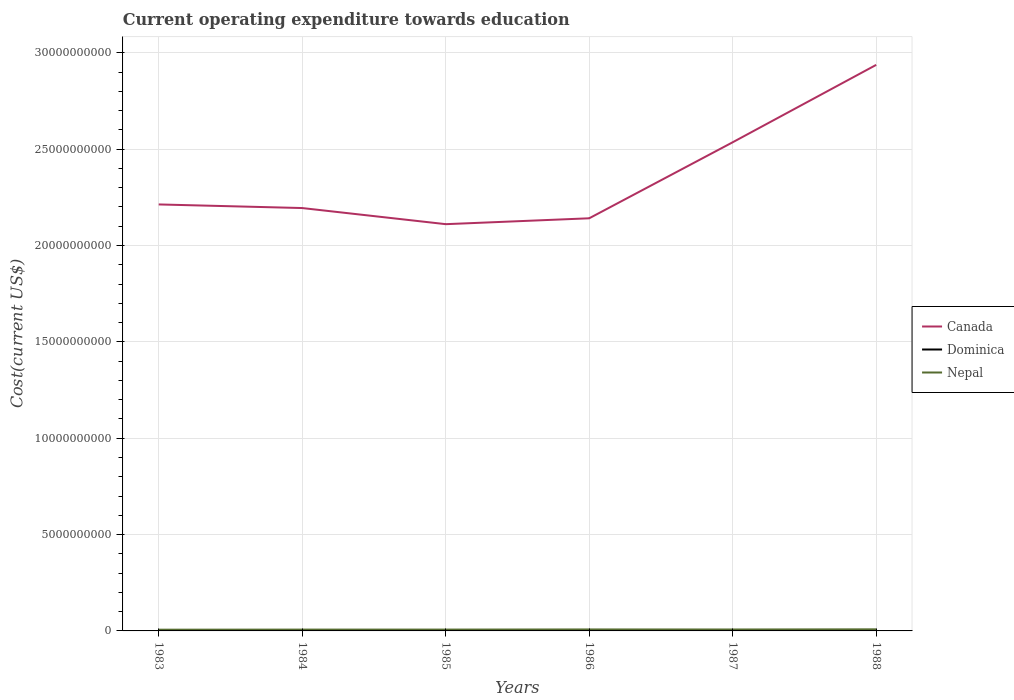Does the line corresponding to Dominica intersect with the line corresponding to Canada?
Keep it short and to the point. No. Is the number of lines equal to the number of legend labels?
Give a very brief answer. Yes. Across all years, what is the maximum expenditure towards education in Nepal?
Make the answer very short. 6.40e+07. In which year was the expenditure towards education in Nepal maximum?
Keep it short and to the point. 1983. What is the total expenditure towards education in Dominica in the graph?
Offer a very short reply. -1.57e+06. What is the difference between the highest and the second highest expenditure towards education in Nepal?
Your response must be concise. 1.85e+07. What is the difference between the highest and the lowest expenditure towards education in Dominica?
Your response must be concise. 3. Is the expenditure towards education in Canada strictly greater than the expenditure towards education in Nepal over the years?
Provide a succinct answer. No. How many lines are there?
Your answer should be compact. 3. How many years are there in the graph?
Keep it short and to the point. 6. Where does the legend appear in the graph?
Your response must be concise. Center right. What is the title of the graph?
Your answer should be very brief. Current operating expenditure towards education. What is the label or title of the Y-axis?
Offer a very short reply. Cost(current US$). What is the Cost(current US$) of Canada in 1983?
Your answer should be very brief. 2.21e+1. What is the Cost(current US$) of Dominica in 1983?
Provide a succinct answer. 4.29e+06. What is the Cost(current US$) of Nepal in 1983?
Your response must be concise. 6.40e+07. What is the Cost(current US$) in Canada in 1984?
Provide a succinct answer. 2.19e+1. What is the Cost(current US$) in Dominica in 1984?
Ensure brevity in your answer.  4.75e+06. What is the Cost(current US$) of Nepal in 1984?
Provide a short and direct response. 6.91e+07. What is the Cost(current US$) in Canada in 1985?
Keep it short and to the point. 2.11e+1. What is the Cost(current US$) in Dominica in 1985?
Your answer should be very brief. 5.04e+06. What is the Cost(current US$) in Nepal in 1985?
Your response must be concise. 6.99e+07. What is the Cost(current US$) in Canada in 1986?
Provide a succinct answer. 2.14e+1. What is the Cost(current US$) in Dominica in 1986?
Provide a short and direct response. 5.92e+06. What is the Cost(current US$) in Nepal in 1986?
Offer a very short reply. 7.70e+07. What is the Cost(current US$) of Canada in 1987?
Ensure brevity in your answer.  2.54e+1. What is the Cost(current US$) of Dominica in 1987?
Make the answer very short. 6.32e+06. What is the Cost(current US$) in Nepal in 1987?
Your response must be concise. 7.49e+07. What is the Cost(current US$) in Canada in 1988?
Your answer should be compact. 2.94e+1. What is the Cost(current US$) in Dominica in 1988?
Offer a very short reply. 6.42e+06. What is the Cost(current US$) in Nepal in 1988?
Your response must be concise. 8.24e+07. Across all years, what is the maximum Cost(current US$) of Canada?
Ensure brevity in your answer.  2.94e+1. Across all years, what is the maximum Cost(current US$) in Dominica?
Your response must be concise. 6.42e+06. Across all years, what is the maximum Cost(current US$) in Nepal?
Ensure brevity in your answer.  8.24e+07. Across all years, what is the minimum Cost(current US$) in Canada?
Ensure brevity in your answer.  2.11e+1. Across all years, what is the minimum Cost(current US$) of Dominica?
Your answer should be very brief. 4.29e+06. Across all years, what is the minimum Cost(current US$) of Nepal?
Provide a succinct answer. 6.40e+07. What is the total Cost(current US$) of Canada in the graph?
Ensure brevity in your answer.  1.41e+11. What is the total Cost(current US$) of Dominica in the graph?
Offer a very short reply. 3.27e+07. What is the total Cost(current US$) in Nepal in the graph?
Your answer should be very brief. 4.37e+08. What is the difference between the Cost(current US$) in Canada in 1983 and that in 1984?
Provide a succinct answer. 1.88e+08. What is the difference between the Cost(current US$) of Dominica in 1983 and that in 1984?
Offer a terse response. -4.55e+05. What is the difference between the Cost(current US$) of Nepal in 1983 and that in 1984?
Your response must be concise. -5.08e+06. What is the difference between the Cost(current US$) of Canada in 1983 and that in 1985?
Ensure brevity in your answer.  1.02e+09. What is the difference between the Cost(current US$) of Dominica in 1983 and that in 1985?
Offer a terse response. -7.48e+05. What is the difference between the Cost(current US$) in Nepal in 1983 and that in 1985?
Make the answer very short. -5.90e+06. What is the difference between the Cost(current US$) of Canada in 1983 and that in 1986?
Your response must be concise. 7.19e+08. What is the difference between the Cost(current US$) in Dominica in 1983 and that in 1986?
Keep it short and to the point. -1.62e+06. What is the difference between the Cost(current US$) of Nepal in 1983 and that in 1986?
Your answer should be very brief. -1.30e+07. What is the difference between the Cost(current US$) in Canada in 1983 and that in 1987?
Your response must be concise. -3.23e+09. What is the difference between the Cost(current US$) of Dominica in 1983 and that in 1987?
Your answer should be very brief. -2.03e+06. What is the difference between the Cost(current US$) in Nepal in 1983 and that in 1987?
Your answer should be very brief. -1.09e+07. What is the difference between the Cost(current US$) of Canada in 1983 and that in 1988?
Provide a short and direct response. -7.24e+09. What is the difference between the Cost(current US$) of Dominica in 1983 and that in 1988?
Offer a very short reply. -2.12e+06. What is the difference between the Cost(current US$) in Nepal in 1983 and that in 1988?
Provide a short and direct response. -1.85e+07. What is the difference between the Cost(current US$) in Canada in 1984 and that in 1985?
Provide a short and direct response. 8.36e+08. What is the difference between the Cost(current US$) of Dominica in 1984 and that in 1985?
Provide a short and direct response. -2.94e+05. What is the difference between the Cost(current US$) in Nepal in 1984 and that in 1985?
Keep it short and to the point. -8.18e+05. What is the difference between the Cost(current US$) of Canada in 1984 and that in 1986?
Offer a very short reply. 5.31e+08. What is the difference between the Cost(current US$) in Dominica in 1984 and that in 1986?
Provide a short and direct response. -1.17e+06. What is the difference between the Cost(current US$) in Nepal in 1984 and that in 1986?
Make the answer very short. -7.92e+06. What is the difference between the Cost(current US$) in Canada in 1984 and that in 1987?
Give a very brief answer. -3.41e+09. What is the difference between the Cost(current US$) in Dominica in 1984 and that in 1987?
Your response must be concise. -1.57e+06. What is the difference between the Cost(current US$) in Nepal in 1984 and that in 1987?
Make the answer very short. -5.84e+06. What is the difference between the Cost(current US$) of Canada in 1984 and that in 1988?
Give a very brief answer. -7.43e+09. What is the difference between the Cost(current US$) in Dominica in 1984 and that in 1988?
Offer a terse response. -1.67e+06. What is the difference between the Cost(current US$) in Nepal in 1984 and that in 1988?
Give a very brief answer. -1.34e+07. What is the difference between the Cost(current US$) in Canada in 1985 and that in 1986?
Provide a succinct answer. -3.05e+08. What is the difference between the Cost(current US$) of Dominica in 1985 and that in 1986?
Provide a short and direct response. -8.74e+05. What is the difference between the Cost(current US$) in Nepal in 1985 and that in 1986?
Give a very brief answer. -7.10e+06. What is the difference between the Cost(current US$) of Canada in 1985 and that in 1987?
Offer a terse response. -4.25e+09. What is the difference between the Cost(current US$) of Dominica in 1985 and that in 1987?
Provide a short and direct response. -1.28e+06. What is the difference between the Cost(current US$) of Nepal in 1985 and that in 1987?
Offer a very short reply. -5.02e+06. What is the difference between the Cost(current US$) of Canada in 1985 and that in 1988?
Provide a succinct answer. -8.27e+09. What is the difference between the Cost(current US$) in Dominica in 1985 and that in 1988?
Your answer should be very brief. -1.37e+06. What is the difference between the Cost(current US$) in Nepal in 1985 and that in 1988?
Give a very brief answer. -1.26e+07. What is the difference between the Cost(current US$) in Canada in 1986 and that in 1987?
Your answer should be very brief. -3.94e+09. What is the difference between the Cost(current US$) in Dominica in 1986 and that in 1987?
Provide a short and direct response. -4.04e+05. What is the difference between the Cost(current US$) in Nepal in 1986 and that in 1987?
Provide a succinct answer. 2.08e+06. What is the difference between the Cost(current US$) of Canada in 1986 and that in 1988?
Your answer should be compact. -7.96e+09. What is the difference between the Cost(current US$) of Dominica in 1986 and that in 1988?
Ensure brevity in your answer.  -4.98e+05. What is the difference between the Cost(current US$) of Nepal in 1986 and that in 1988?
Provide a succinct answer. -5.48e+06. What is the difference between the Cost(current US$) of Canada in 1987 and that in 1988?
Provide a succinct answer. -4.02e+09. What is the difference between the Cost(current US$) of Dominica in 1987 and that in 1988?
Provide a short and direct response. -9.50e+04. What is the difference between the Cost(current US$) of Nepal in 1987 and that in 1988?
Provide a succinct answer. -7.56e+06. What is the difference between the Cost(current US$) in Canada in 1983 and the Cost(current US$) in Dominica in 1984?
Ensure brevity in your answer.  2.21e+1. What is the difference between the Cost(current US$) in Canada in 1983 and the Cost(current US$) in Nepal in 1984?
Give a very brief answer. 2.21e+1. What is the difference between the Cost(current US$) in Dominica in 1983 and the Cost(current US$) in Nepal in 1984?
Your answer should be compact. -6.48e+07. What is the difference between the Cost(current US$) in Canada in 1983 and the Cost(current US$) in Dominica in 1985?
Keep it short and to the point. 2.21e+1. What is the difference between the Cost(current US$) in Canada in 1983 and the Cost(current US$) in Nepal in 1985?
Give a very brief answer. 2.21e+1. What is the difference between the Cost(current US$) of Dominica in 1983 and the Cost(current US$) of Nepal in 1985?
Give a very brief answer. -6.56e+07. What is the difference between the Cost(current US$) in Canada in 1983 and the Cost(current US$) in Dominica in 1986?
Give a very brief answer. 2.21e+1. What is the difference between the Cost(current US$) of Canada in 1983 and the Cost(current US$) of Nepal in 1986?
Provide a short and direct response. 2.21e+1. What is the difference between the Cost(current US$) of Dominica in 1983 and the Cost(current US$) of Nepal in 1986?
Your answer should be compact. -7.27e+07. What is the difference between the Cost(current US$) in Canada in 1983 and the Cost(current US$) in Dominica in 1987?
Make the answer very short. 2.21e+1. What is the difference between the Cost(current US$) of Canada in 1983 and the Cost(current US$) of Nepal in 1987?
Your answer should be compact. 2.21e+1. What is the difference between the Cost(current US$) in Dominica in 1983 and the Cost(current US$) in Nepal in 1987?
Give a very brief answer. -7.06e+07. What is the difference between the Cost(current US$) in Canada in 1983 and the Cost(current US$) in Dominica in 1988?
Your answer should be very brief. 2.21e+1. What is the difference between the Cost(current US$) in Canada in 1983 and the Cost(current US$) in Nepal in 1988?
Give a very brief answer. 2.20e+1. What is the difference between the Cost(current US$) of Dominica in 1983 and the Cost(current US$) of Nepal in 1988?
Give a very brief answer. -7.82e+07. What is the difference between the Cost(current US$) in Canada in 1984 and the Cost(current US$) in Dominica in 1985?
Give a very brief answer. 2.19e+1. What is the difference between the Cost(current US$) in Canada in 1984 and the Cost(current US$) in Nepal in 1985?
Your response must be concise. 2.19e+1. What is the difference between the Cost(current US$) in Dominica in 1984 and the Cost(current US$) in Nepal in 1985?
Ensure brevity in your answer.  -6.51e+07. What is the difference between the Cost(current US$) in Canada in 1984 and the Cost(current US$) in Dominica in 1986?
Keep it short and to the point. 2.19e+1. What is the difference between the Cost(current US$) in Canada in 1984 and the Cost(current US$) in Nepal in 1986?
Your answer should be compact. 2.19e+1. What is the difference between the Cost(current US$) of Dominica in 1984 and the Cost(current US$) of Nepal in 1986?
Provide a succinct answer. -7.22e+07. What is the difference between the Cost(current US$) of Canada in 1984 and the Cost(current US$) of Dominica in 1987?
Provide a short and direct response. 2.19e+1. What is the difference between the Cost(current US$) of Canada in 1984 and the Cost(current US$) of Nepal in 1987?
Provide a short and direct response. 2.19e+1. What is the difference between the Cost(current US$) of Dominica in 1984 and the Cost(current US$) of Nepal in 1987?
Your answer should be compact. -7.01e+07. What is the difference between the Cost(current US$) in Canada in 1984 and the Cost(current US$) in Dominica in 1988?
Make the answer very short. 2.19e+1. What is the difference between the Cost(current US$) in Canada in 1984 and the Cost(current US$) in Nepal in 1988?
Provide a succinct answer. 2.19e+1. What is the difference between the Cost(current US$) of Dominica in 1984 and the Cost(current US$) of Nepal in 1988?
Give a very brief answer. -7.77e+07. What is the difference between the Cost(current US$) in Canada in 1985 and the Cost(current US$) in Dominica in 1986?
Give a very brief answer. 2.11e+1. What is the difference between the Cost(current US$) of Canada in 1985 and the Cost(current US$) of Nepal in 1986?
Give a very brief answer. 2.10e+1. What is the difference between the Cost(current US$) of Dominica in 1985 and the Cost(current US$) of Nepal in 1986?
Ensure brevity in your answer.  -7.19e+07. What is the difference between the Cost(current US$) in Canada in 1985 and the Cost(current US$) in Dominica in 1987?
Your answer should be very brief. 2.11e+1. What is the difference between the Cost(current US$) in Canada in 1985 and the Cost(current US$) in Nepal in 1987?
Offer a terse response. 2.10e+1. What is the difference between the Cost(current US$) in Dominica in 1985 and the Cost(current US$) in Nepal in 1987?
Ensure brevity in your answer.  -6.99e+07. What is the difference between the Cost(current US$) of Canada in 1985 and the Cost(current US$) of Dominica in 1988?
Ensure brevity in your answer.  2.11e+1. What is the difference between the Cost(current US$) in Canada in 1985 and the Cost(current US$) in Nepal in 1988?
Keep it short and to the point. 2.10e+1. What is the difference between the Cost(current US$) in Dominica in 1985 and the Cost(current US$) in Nepal in 1988?
Ensure brevity in your answer.  -7.74e+07. What is the difference between the Cost(current US$) in Canada in 1986 and the Cost(current US$) in Dominica in 1987?
Ensure brevity in your answer.  2.14e+1. What is the difference between the Cost(current US$) of Canada in 1986 and the Cost(current US$) of Nepal in 1987?
Provide a short and direct response. 2.13e+1. What is the difference between the Cost(current US$) in Dominica in 1986 and the Cost(current US$) in Nepal in 1987?
Your answer should be very brief. -6.90e+07. What is the difference between the Cost(current US$) of Canada in 1986 and the Cost(current US$) of Dominica in 1988?
Keep it short and to the point. 2.14e+1. What is the difference between the Cost(current US$) in Canada in 1986 and the Cost(current US$) in Nepal in 1988?
Your answer should be very brief. 2.13e+1. What is the difference between the Cost(current US$) in Dominica in 1986 and the Cost(current US$) in Nepal in 1988?
Offer a terse response. -7.65e+07. What is the difference between the Cost(current US$) in Canada in 1987 and the Cost(current US$) in Dominica in 1988?
Give a very brief answer. 2.53e+1. What is the difference between the Cost(current US$) in Canada in 1987 and the Cost(current US$) in Nepal in 1988?
Your response must be concise. 2.53e+1. What is the difference between the Cost(current US$) in Dominica in 1987 and the Cost(current US$) in Nepal in 1988?
Your answer should be very brief. -7.61e+07. What is the average Cost(current US$) of Canada per year?
Offer a very short reply. 2.36e+1. What is the average Cost(current US$) in Dominica per year?
Keep it short and to the point. 5.46e+06. What is the average Cost(current US$) of Nepal per year?
Provide a short and direct response. 7.29e+07. In the year 1983, what is the difference between the Cost(current US$) of Canada and Cost(current US$) of Dominica?
Offer a very short reply. 2.21e+1. In the year 1983, what is the difference between the Cost(current US$) of Canada and Cost(current US$) of Nepal?
Provide a succinct answer. 2.21e+1. In the year 1983, what is the difference between the Cost(current US$) of Dominica and Cost(current US$) of Nepal?
Your answer should be very brief. -5.97e+07. In the year 1984, what is the difference between the Cost(current US$) of Canada and Cost(current US$) of Dominica?
Keep it short and to the point. 2.19e+1. In the year 1984, what is the difference between the Cost(current US$) in Canada and Cost(current US$) in Nepal?
Your answer should be compact. 2.19e+1. In the year 1984, what is the difference between the Cost(current US$) in Dominica and Cost(current US$) in Nepal?
Your response must be concise. -6.43e+07. In the year 1985, what is the difference between the Cost(current US$) in Canada and Cost(current US$) in Dominica?
Your answer should be compact. 2.11e+1. In the year 1985, what is the difference between the Cost(current US$) in Canada and Cost(current US$) in Nepal?
Your answer should be compact. 2.10e+1. In the year 1985, what is the difference between the Cost(current US$) in Dominica and Cost(current US$) in Nepal?
Ensure brevity in your answer.  -6.48e+07. In the year 1986, what is the difference between the Cost(current US$) in Canada and Cost(current US$) in Dominica?
Give a very brief answer. 2.14e+1. In the year 1986, what is the difference between the Cost(current US$) in Canada and Cost(current US$) in Nepal?
Your answer should be compact. 2.13e+1. In the year 1986, what is the difference between the Cost(current US$) of Dominica and Cost(current US$) of Nepal?
Offer a terse response. -7.11e+07. In the year 1987, what is the difference between the Cost(current US$) in Canada and Cost(current US$) in Dominica?
Give a very brief answer. 2.53e+1. In the year 1987, what is the difference between the Cost(current US$) in Canada and Cost(current US$) in Nepal?
Your answer should be compact. 2.53e+1. In the year 1987, what is the difference between the Cost(current US$) of Dominica and Cost(current US$) of Nepal?
Provide a short and direct response. -6.86e+07. In the year 1988, what is the difference between the Cost(current US$) of Canada and Cost(current US$) of Dominica?
Provide a short and direct response. 2.94e+1. In the year 1988, what is the difference between the Cost(current US$) of Canada and Cost(current US$) of Nepal?
Make the answer very short. 2.93e+1. In the year 1988, what is the difference between the Cost(current US$) of Dominica and Cost(current US$) of Nepal?
Offer a terse response. -7.60e+07. What is the ratio of the Cost(current US$) in Canada in 1983 to that in 1984?
Provide a short and direct response. 1.01. What is the ratio of the Cost(current US$) of Dominica in 1983 to that in 1984?
Provide a short and direct response. 0.9. What is the ratio of the Cost(current US$) in Nepal in 1983 to that in 1984?
Ensure brevity in your answer.  0.93. What is the ratio of the Cost(current US$) in Canada in 1983 to that in 1985?
Offer a terse response. 1.05. What is the ratio of the Cost(current US$) in Dominica in 1983 to that in 1985?
Provide a succinct answer. 0.85. What is the ratio of the Cost(current US$) in Nepal in 1983 to that in 1985?
Offer a very short reply. 0.92. What is the ratio of the Cost(current US$) of Canada in 1983 to that in 1986?
Make the answer very short. 1.03. What is the ratio of the Cost(current US$) of Dominica in 1983 to that in 1986?
Your answer should be very brief. 0.73. What is the ratio of the Cost(current US$) in Nepal in 1983 to that in 1986?
Ensure brevity in your answer.  0.83. What is the ratio of the Cost(current US$) of Canada in 1983 to that in 1987?
Give a very brief answer. 0.87. What is the ratio of the Cost(current US$) of Dominica in 1983 to that in 1987?
Your answer should be compact. 0.68. What is the ratio of the Cost(current US$) in Nepal in 1983 to that in 1987?
Ensure brevity in your answer.  0.85. What is the ratio of the Cost(current US$) of Canada in 1983 to that in 1988?
Ensure brevity in your answer.  0.75. What is the ratio of the Cost(current US$) of Dominica in 1983 to that in 1988?
Offer a terse response. 0.67. What is the ratio of the Cost(current US$) of Nepal in 1983 to that in 1988?
Ensure brevity in your answer.  0.78. What is the ratio of the Cost(current US$) of Canada in 1984 to that in 1985?
Your answer should be compact. 1.04. What is the ratio of the Cost(current US$) in Dominica in 1984 to that in 1985?
Ensure brevity in your answer.  0.94. What is the ratio of the Cost(current US$) in Nepal in 1984 to that in 1985?
Keep it short and to the point. 0.99. What is the ratio of the Cost(current US$) in Canada in 1984 to that in 1986?
Your answer should be compact. 1.02. What is the ratio of the Cost(current US$) of Dominica in 1984 to that in 1986?
Keep it short and to the point. 0.8. What is the ratio of the Cost(current US$) of Nepal in 1984 to that in 1986?
Offer a very short reply. 0.9. What is the ratio of the Cost(current US$) in Canada in 1984 to that in 1987?
Your answer should be compact. 0.87. What is the ratio of the Cost(current US$) in Dominica in 1984 to that in 1987?
Keep it short and to the point. 0.75. What is the ratio of the Cost(current US$) of Nepal in 1984 to that in 1987?
Provide a succinct answer. 0.92. What is the ratio of the Cost(current US$) in Canada in 1984 to that in 1988?
Make the answer very short. 0.75. What is the ratio of the Cost(current US$) of Dominica in 1984 to that in 1988?
Provide a short and direct response. 0.74. What is the ratio of the Cost(current US$) of Nepal in 1984 to that in 1988?
Ensure brevity in your answer.  0.84. What is the ratio of the Cost(current US$) of Canada in 1985 to that in 1986?
Provide a succinct answer. 0.99. What is the ratio of the Cost(current US$) in Dominica in 1985 to that in 1986?
Your answer should be very brief. 0.85. What is the ratio of the Cost(current US$) in Nepal in 1985 to that in 1986?
Make the answer very short. 0.91. What is the ratio of the Cost(current US$) of Canada in 1985 to that in 1987?
Make the answer very short. 0.83. What is the ratio of the Cost(current US$) in Dominica in 1985 to that in 1987?
Make the answer very short. 0.8. What is the ratio of the Cost(current US$) in Nepal in 1985 to that in 1987?
Offer a very short reply. 0.93. What is the ratio of the Cost(current US$) in Canada in 1985 to that in 1988?
Keep it short and to the point. 0.72. What is the ratio of the Cost(current US$) of Dominica in 1985 to that in 1988?
Make the answer very short. 0.79. What is the ratio of the Cost(current US$) in Nepal in 1985 to that in 1988?
Your answer should be compact. 0.85. What is the ratio of the Cost(current US$) in Canada in 1986 to that in 1987?
Provide a short and direct response. 0.84. What is the ratio of the Cost(current US$) of Dominica in 1986 to that in 1987?
Offer a terse response. 0.94. What is the ratio of the Cost(current US$) in Nepal in 1986 to that in 1987?
Give a very brief answer. 1.03. What is the ratio of the Cost(current US$) of Canada in 1986 to that in 1988?
Provide a succinct answer. 0.73. What is the ratio of the Cost(current US$) in Dominica in 1986 to that in 1988?
Keep it short and to the point. 0.92. What is the ratio of the Cost(current US$) of Nepal in 1986 to that in 1988?
Give a very brief answer. 0.93. What is the ratio of the Cost(current US$) of Canada in 1987 to that in 1988?
Your answer should be compact. 0.86. What is the ratio of the Cost(current US$) of Dominica in 1987 to that in 1988?
Give a very brief answer. 0.99. What is the ratio of the Cost(current US$) of Nepal in 1987 to that in 1988?
Make the answer very short. 0.91. What is the difference between the highest and the second highest Cost(current US$) of Canada?
Ensure brevity in your answer.  4.02e+09. What is the difference between the highest and the second highest Cost(current US$) in Dominica?
Give a very brief answer. 9.50e+04. What is the difference between the highest and the second highest Cost(current US$) of Nepal?
Your response must be concise. 5.48e+06. What is the difference between the highest and the lowest Cost(current US$) in Canada?
Ensure brevity in your answer.  8.27e+09. What is the difference between the highest and the lowest Cost(current US$) in Dominica?
Your answer should be very brief. 2.12e+06. What is the difference between the highest and the lowest Cost(current US$) of Nepal?
Keep it short and to the point. 1.85e+07. 